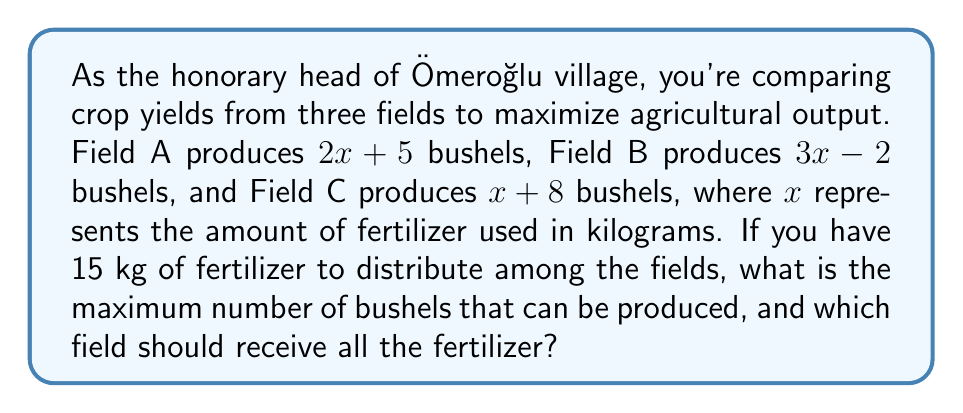Give your solution to this math problem. Let's approach this step-by-step:

1) We have three equations representing the yield of each field:
   Field A: $y_A = 2x + 5$
   Field B: $y_B = 3x - 2$
   Field C: $y_C = x + 8$

2) We need to compare these equations when $x = 15$ (since we have 15 kg of fertilizer):

   For Field A: $y_A = 2(15) + 5 = 30 + 5 = 35$ bushels
   For Field B: $y_B = 3(15) - 2 = 45 - 2 = 43$ bushels
   For Field C: $y_C = 15 + 8 = 23$ bushels

3) To maximize output, we should use all the fertilizer on the field that produces the highest yield. From our calculations, we can see that Field B produces the most bushels.

4) Therefore, the maximum number of bushels that can be produced is 43, which is achieved by using all 15 kg of fertilizer on Field B.
Answer: 43 bushels; Field B 